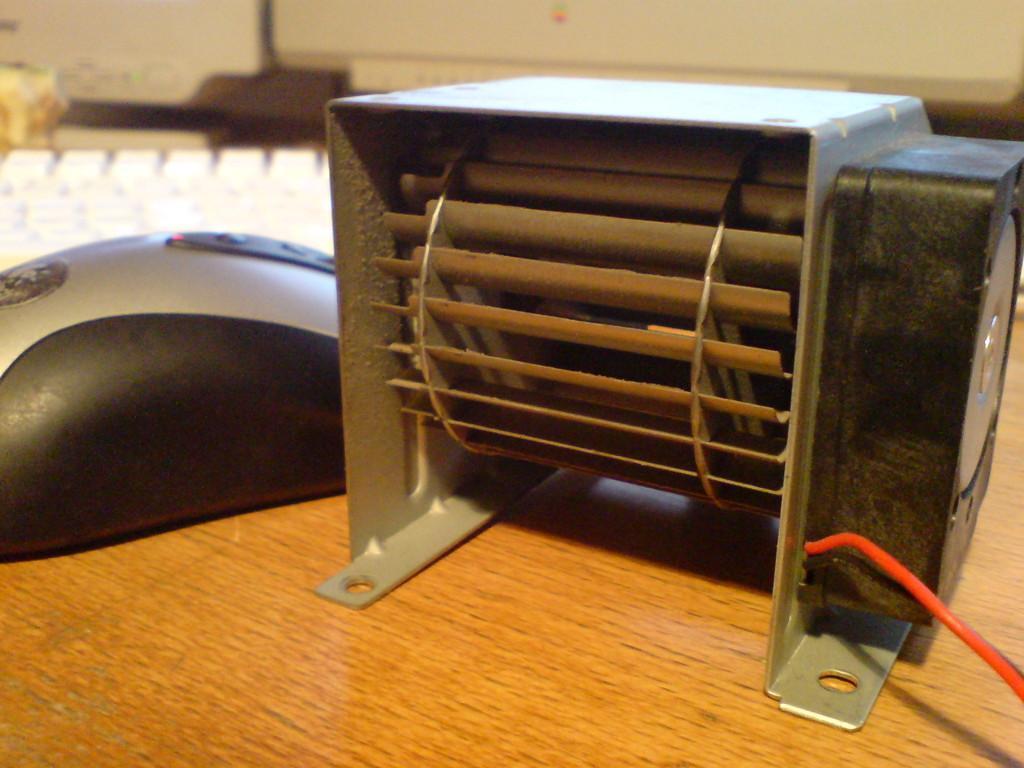Describe this image in one or two sentences. In the right side it is an electronic machine. In the left side it is a mouse and there is a key board which is in white color. 